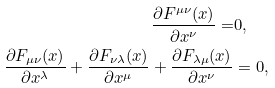Convert formula to latex. <formula><loc_0><loc_0><loc_500><loc_500>\frac { \partial F ^ { \mu \nu } ( x ) } { \partial x ^ { \nu } } = & 0 , \\ \frac { \partial F _ { \mu \nu } ( x ) } { \partial x ^ { \lambda } } + \frac { \partial F _ { \nu \lambda } ( x ) } { \partial x ^ { \mu } } + \frac { \partial F _ { \lambda \mu } ( x ) } { \partial x ^ { \nu } } & = 0 ,</formula> 